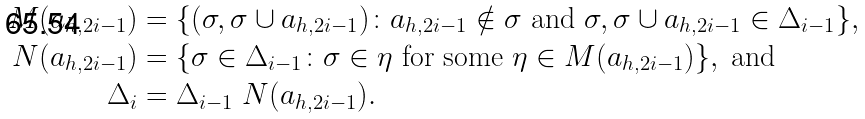Convert formula to latex. <formula><loc_0><loc_0><loc_500><loc_500>M ( a _ { h , 2 i - 1 } ) & = \{ ( \sigma , \sigma \cup a _ { h , 2 i - 1 } ) \colon a _ { h , 2 i - 1 } \notin \sigma \text { and } \sigma , \sigma \cup a _ { h , 2 i - 1 } \in \Delta _ { i - 1 } \} , \\ N ( a _ { h , 2 i - 1 } ) & = \{ \sigma \in \Delta _ { i - 1 } \colon \sigma \in \eta \text { for some } \eta \in M ( a _ { h , 2 i - 1 } ) \} , \text { and} \\ \Delta _ { i } & = \Delta _ { i - 1 } \ N ( a _ { h , 2 i - 1 } ) .</formula> 